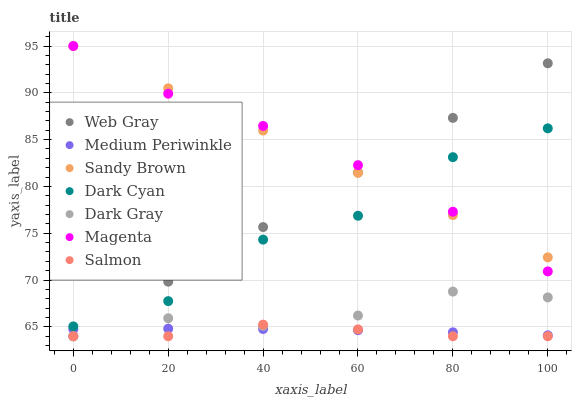Does Salmon have the minimum area under the curve?
Answer yes or no. Yes. Does Magenta have the maximum area under the curve?
Answer yes or no. Yes. Does Medium Periwinkle have the minimum area under the curve?
Answer yes or no. No. Does Medium Periwinkle have the maximum area under the curve?
Answer yes or no. No. Is Sandy Brown the smoothest?
Answer yes or no. Yes. Is Dark Cyan the roughest?
Answer yes or no. Yes. Is Salmon the smoothest?
Answer yes or no. No. Is Salmon the roughest?
Answer yes or no. No. Does Web Gray have the lowest value?
Answer yes or no. Yes. Does Medium Periwinkle have the lowest value?
Answer yes or no. No. Does Sandy Brown have the highest value?
Answer yes or no. Yes. Does Salmon have the highest value?
Answer yes or no. No. Is Dark Gray less than Sandy Brown?
Answer yes or no. Yes. Is Magenta greater than Salmon?
Answer yes or no. Yes. Does Magenta intersect Dark Cyan?
Answer yes or no. Yes. Is Magenta less than Dark Cyan?
Answer yes or no. No. Is Magenta greater than Dark Cyan?
Answer yes or no. No. Does Dark Gray intersect Sandy Brown?
Answer yes or no. No. 